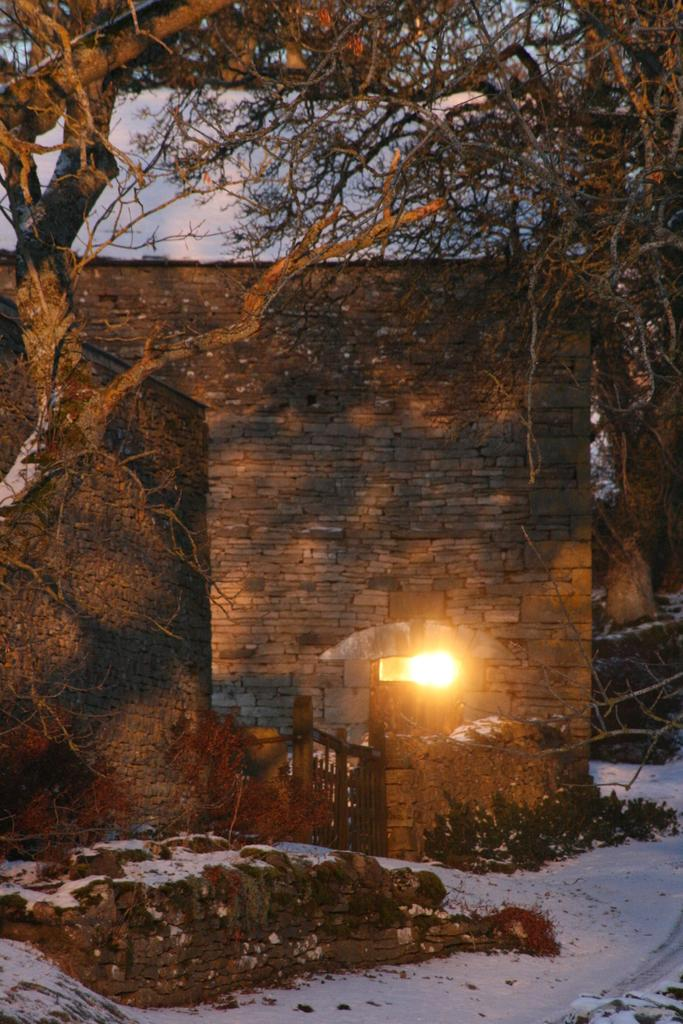What type of structures can be seen in the image? There are houses in the image. What is in front of the houses? There is a wooden gate and a light in front of the houses. What type of vegetation is present in the image? There are trees and plants in the image. What is the condition of the surface in the image? There is snow on the surface in the image. What can be seen in the background of the image? The sky is visible in the background of the image. How many cakes are displayed on the wooden gate in the image? There are no cakes present in the image. What type of shoes can be seen on the trees in the image? There are no shoes visible in the image, as the image does not depict any shoes or people wearing them. 